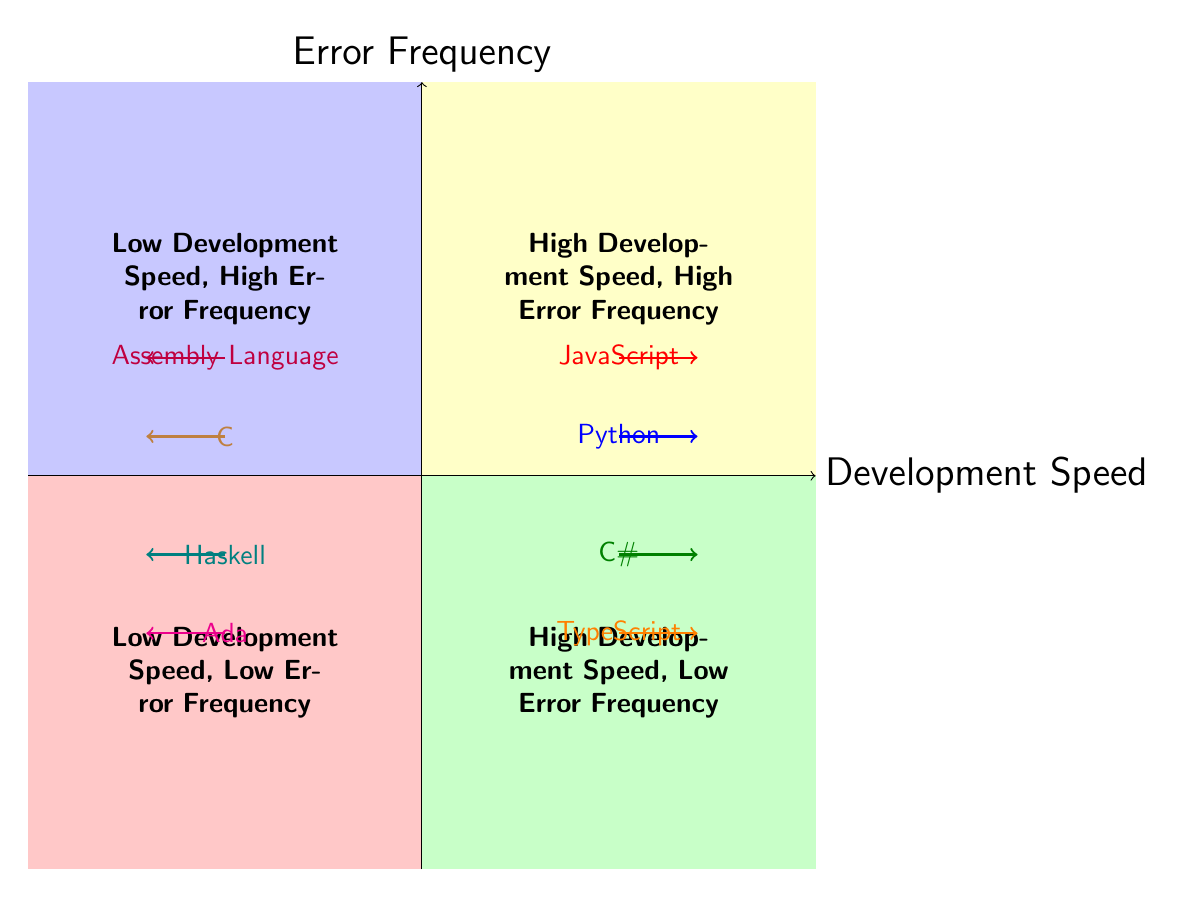What languages are in the "High Development Speed, High Error Frequency" quadrant? By examining the quadrant labeled "High Development Speed, High Error Frequency," we see two languages listed: JavaScript and Python. They are positioned in the top-right quadrant, indicating they fit both criteria.
Answer: JavaScript, Python How many languages are represented in the "Low Development Speed, Low Error Frequency" quadrant? In the quadrant labeled "Low Development Speed, Low Error Frequency," there are two languages mentioned: Haskell and Ada. Counting these, we find that there are exactly two languages represented.
Answer: 2 Which language is positioned lower in the "High Development Speed, Low Error Frequency" quadrant? In the "High Development Speed, Low Error Frequency" quadrant, we observe two languages: C# and TypeScript. C# is positioned higher (near the top) compared to TypeScript, which is lower in this quadrant. Therefore, TypeScript is the one positioned lower.
Answer: TypeScript What can be inferred about Assembly Language regarding development speed and error frequency? Assembly Language is placed in the "Low Development Speed, High Error Frequency" quadrant. This suggests that it requires more time to write, and it is easier to introduce errors while using it, summarizing its development challenges and error propensity.
Answer: Low Development Speed, High Error Frequency Which programming language shows a balance of development speed and low error frequency? Review of the quadrant chart indicates that C# is in the "High Development Speed, Low Error Frequency" quadrant. This placement illustrates that it achieves a good balance between fast development and a low incidence of errors.
Answer: C# What type of language is TypeScript considered in this diagram concerning error frequency? TypeScript is found in the "High Development Speed, Low Error Frequency" quadrant. This indicates that it is categorized as a language that enables rapid development while minimizing errors, which is typical of a strongly typed language due to its type safety features.
Answer: Strongly Typed Language Which quadrant contains languages that are both low in development speed and high in error frequency? The quadrant labeled "Low Development Speed, High Error Frequency" holds languages that are identified as slow to develop while also being prone to errors. This quadrant specifically represents this combination of traits.
Answer: Low Development Speed, High Error Frequency What distinguishes Haskell and Ada in the context of development speed and error frequency? Both Haskell and Ada are positioned in the "Low Development Speed, Low Error Frequency" quadrant. This indicates that, although they might take more time to develop with, they show a low risk of introducing errors, thanks to their strong typing and reliable programming paradigms.
Answer: Low Development Speed, Low Error Frequency 